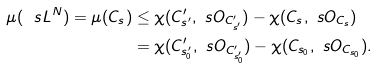Convert formula to latex. <formula><loc_0><loc_0><loc_500><loc_500>\mu ( \ s L ^ { N } ) = \mu ( C _ { s } ) & \leq \chi ( C ^ { \prime } _ { s ^ { \prime } } , \ s O _ { C ^ { \prime } _ { s ^ { \prime } } } ) - \chi ( C _ { s } , \ s O _ { C _ { s } } ) \\ & = \chi ( C ^ { \prime } _ { s ^ { \prime } _ { 0 } } , \ s O _ { C ^ { \prime } _ { s ^ { \prime } _ { 0 } } } ) - \chi ( C _ { s _ { 0 } } , \ s O _ { C _ { s _ { 0 } } } ) .</formula> 